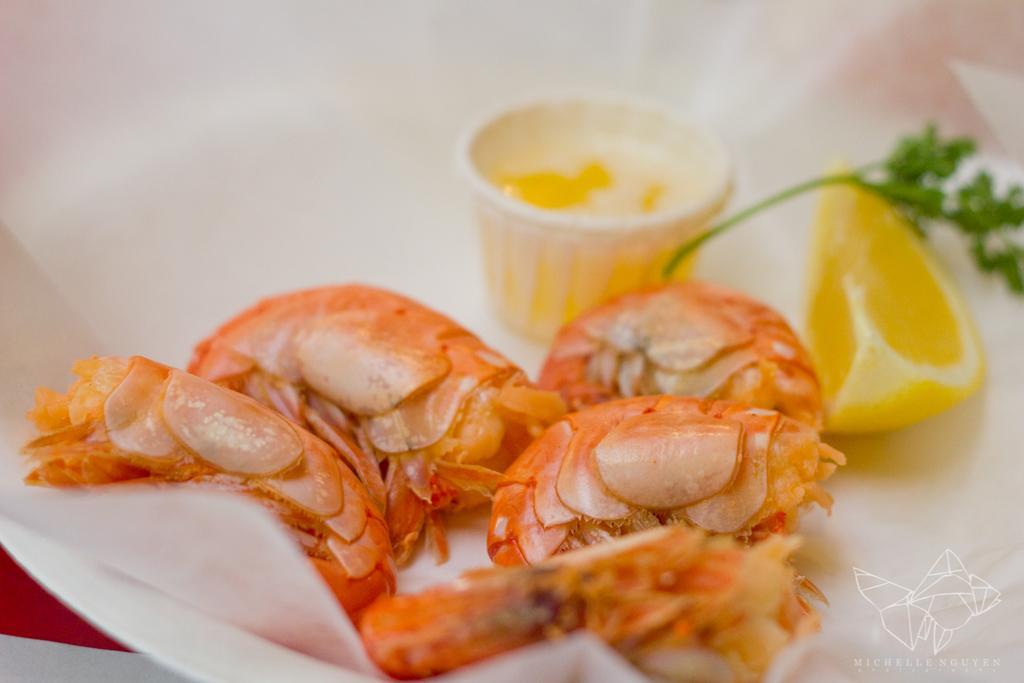How would you summarize this image in a sentence or two? In this image there are prawns in the plate. 